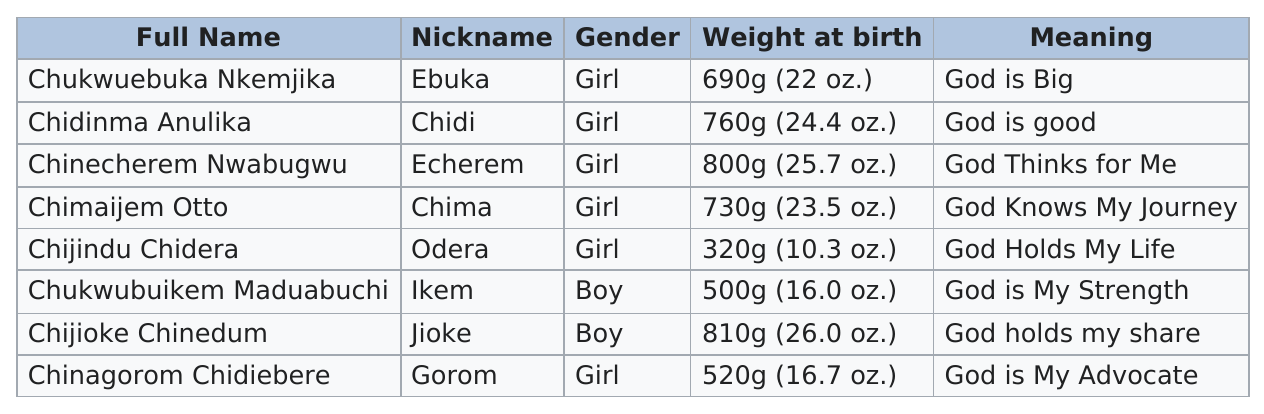Point out several critical features in this image. Jioke, who weighed the most, was the subject of the inquiry. It is confirmed that two boys were born. Out of the eight babies, two of them were boys. Of the girls weighed, how many weighed at least 25.0 ounces? Eight individuals are listed in total. 